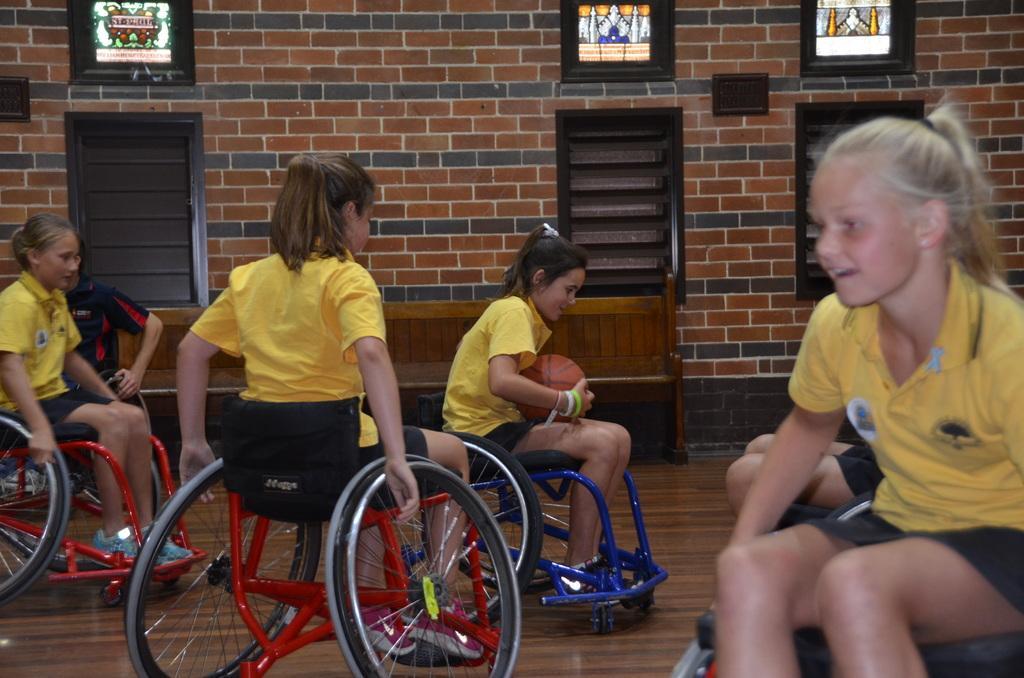Could you give a brief overview of what you see in this image? In this image I can see in he middle few girls are sitting on the wheelchairs, they are wearing yellow color t-shirts. In the middle a girl is holding the ball. In the background there is the wooden bench chair, at the top it looks like there are photo frames with lights. 